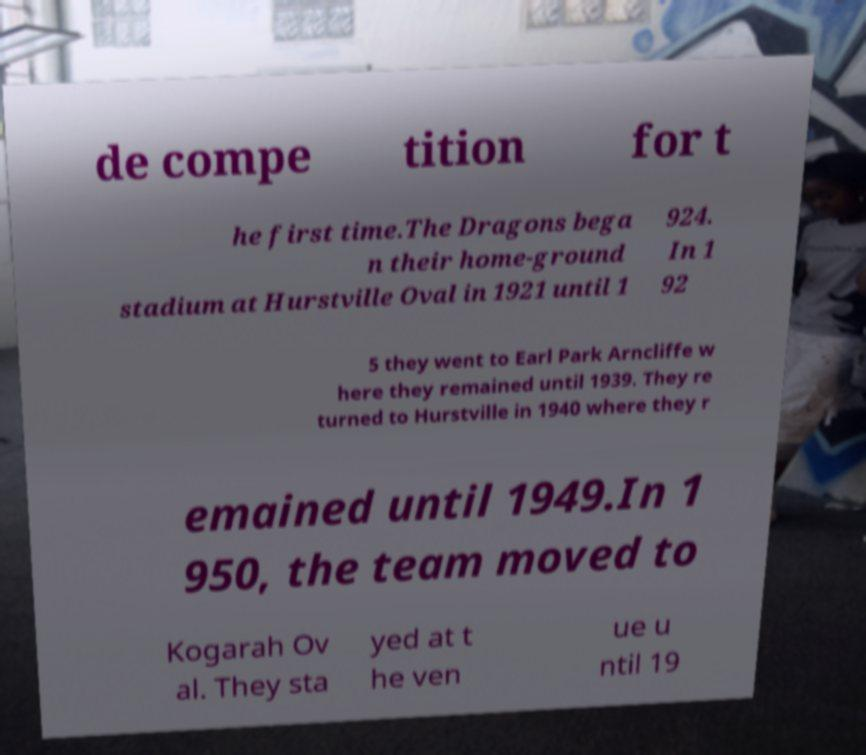For documentation purposes, I need the text within this image transcribed. Could you provide that? de compe tition for t he first time.The Dragons bega n their home-ground stadium at Hurstville Oval in 1921 until 1 924. In 1 92 5 they went to Earl Park Arncliffe w here they remained until 1939. They re turned to Hurstville in 1940 where they r emained until 1949.In 1 950, the team moved to Kogarah Ov al. They sta yed at t he ven ue u ntil 19 